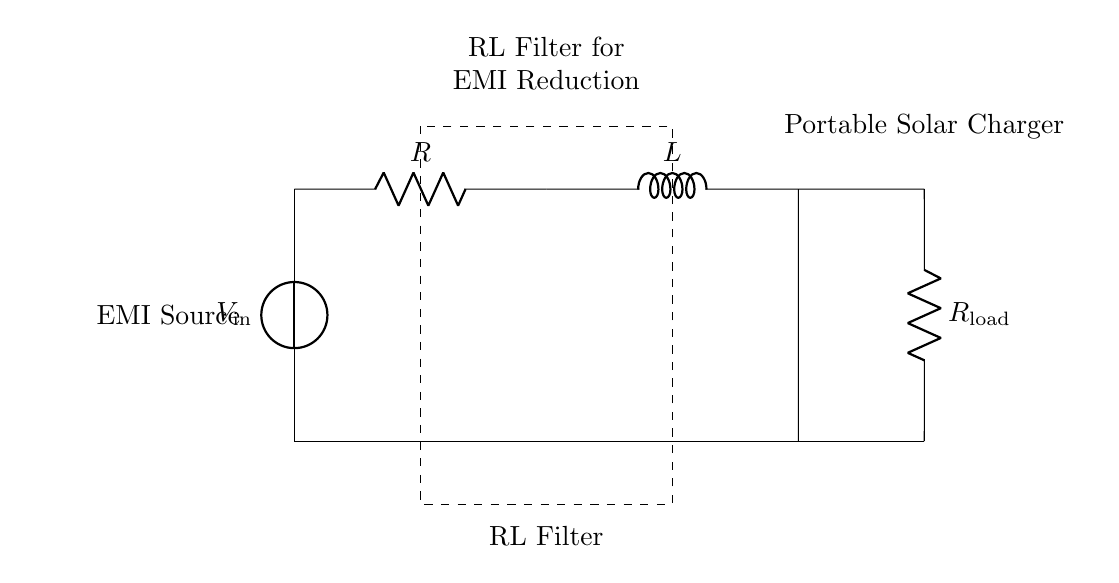What components are in the RL filter? The components in the RL filter are a resistor (R) and an inductor (L). The diagram clearly shows both components connected in series, which constitutes the RL filter part of the circuit.
Answer: Resistor and inductor What is the role of the resistor in this circuit? The resistor in this circuit is used to limit the current flowing through the inductor, assisting in voltage division and helping to filter out unwanted electromagnetic interference. The diagram indicates its position in the series with the inductor.
Answer: Current limitation What is the configuration of the RL filter? The RL filter is configured in series, as both the resistor and inductor are connected end-to-end along the same path, which is evident from the layout in the diagram.
Answer: Series How does the RL filter reduce electromagnetic interference? The RL filter reduces electromagnetic interference by allowing certain frequencies to pass while attenuating others, due to the inductive reactance that increases with frequency. This behavior is characteristic of RL circuits and can be understood from the frequency response of the filter represented in the circuit.
Answer: By attenuating certain frequencies What is the function of the load resistor in this circuit? The load resistor (R_load) serves to represent the electrical load that the portable solar charger must power. It can be identified in the circuit as connected after the RL filter. This resistor’s presence is crucial for demonstrating how the filtered current is delivered to a load.
Answer: Load representation What would happen to the circuit without the inductor? Without the inductor, the circuit would lose its filtering capability, leading to higher levels of electromagnetic interference reaching the load. The inductor's absence would prevent the circuit from achieving its intended function, a conclusion drawn from understanding the role of inductance in filtering applications.
Answer: Increased interference 